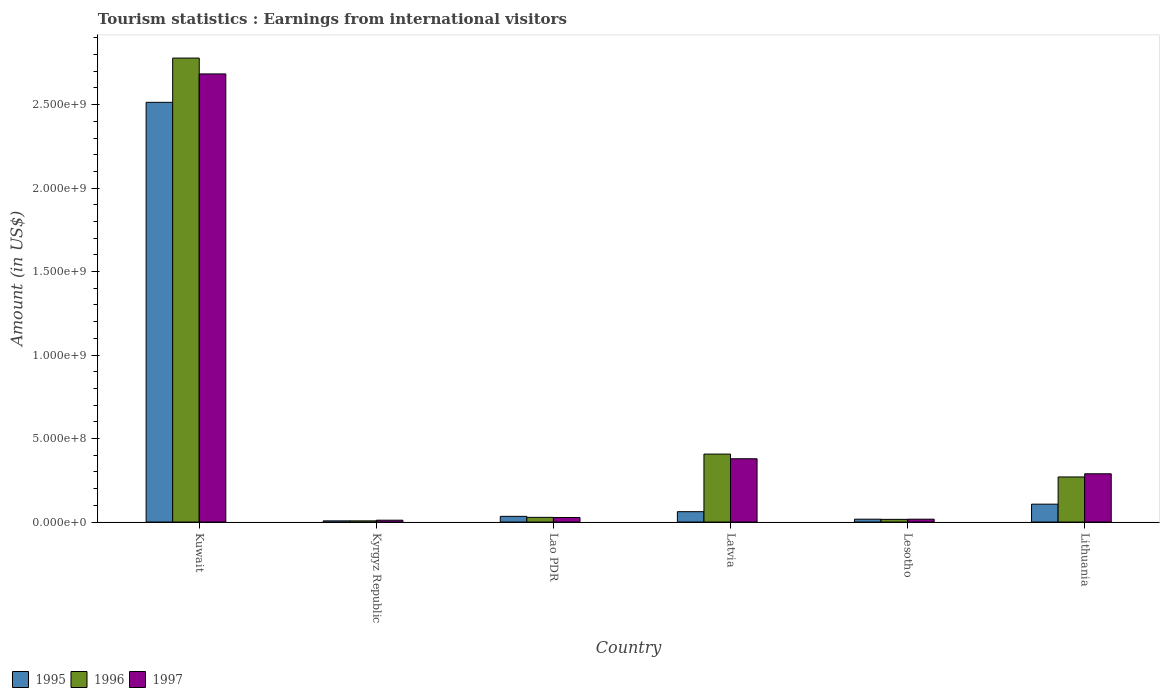What is the label of the 5th group of bars from the left?
Your answer should be compact. Lesotho. What is the earnings from international visitors in 1995 in Lao PDR?
Your response must be concise. 3.40e+07. Across all countries, what is the maximum earnings from international visitors in 1997?
Provide a short and direct response. 2.68e+09. Across all countries, what is the minimum earnings from international visitors in 1997?
Keep it short and to the point. 1.10e+07. In which country was the earnings from international visitors in 1997 maximum?
Make the answer very short. Kuwait. In which country was the earnings from international visitors in 1996 minimum?
Your answer should be compact. Kyrgyz Republic. What is the total earnings from international visitors in 1995 in the graph?
Keep it short and to the point. 2.74e+09. What is the difference between the earnings from international visitors in 1996 in Kuwait and that in Kyrgyz Republic?
Your response must be concise. 2.77e+09. What is the difference between the earnings from international visitors in 1996 in Kyrgyz Republic and the earnings from international visitors in 1997 in Lithuania?
Your answer should be compact. -2.82e+08. What is the average earnings from international visitors in 1996 per country?
Offer a terse response. 5.84e+08. What is the difference between the earnings from international visitors of/in 1997 and earnings from international visitors of/in 1995 in Lao PDR?
Make the answer very short. -7.00e+06. In how many countries, is the earnings from international visitors in 1995 greater than 1300000000 US$?
Keep it short and to the point. 1. What is the ratio of the earnings from international visitors in 1997 in Lao PDR to that in Latvia?
Provide a succinct answer. 0.07. Is the earnings from international visitors in 1996 in Lesotho less than that in Lithuania?
Ensure brevity in your answer.  Yes. What is the difference between the highest and the second highest earnings from international visitors in 1995?
Your answer should be very brief. 2.45e+09. What is the difference between the highest and the lowest earnings from international visitors in 1997?
Provide a succinct answer. 2.67e+09. What does the 1st bar from the right in Kyrgyz Republic represents?
Offer a terse response. 1997. How many bars are there?
Provide a succinct answer. 18. What is the difference between two consecutive major ticks on the Y-axis?
Provide a short and direct response. 5.00e+08. How many legend labels are there?
Your answer should be compact. 3. How are the legend labels stacked?
Offer a very short reply. Horizontal. What is the title of the graph?
Your answer should be very brief. Tourism statistics : Earnings from international visitors. Does "1982" appear as one of the legend labels in the graph?
Keep it short and to the point. No. What is the label or title of the X-axis?
Your response must be concise. Country. What is the label or title of the Y-axis?
Provide a succinct answer. Amount (in US$). What is the Amount (in US$) in 1995 in Kuwait?
Offer a very short reply. 2.51e+09. What is the Amount (in US$) in 1996 in Kuwait?
Keep it short and to the point. 2.78e+09. What is the Amount (in US$) of 1997 in Kuwait?
Ensure brevity in your answer.  2.68e+09. What is the Amount (in US$) of 1996 in Kyrgyz Republic?
Provide a succinct answer. 7.00e+06. What is the Amount (in US$) in 1997 in Kyrgyz Republic?
Your answer should be very brief. 1.10e+07. What is the Amount (in US$) of 1995 in Lao PDR?
Your answer should be very brief. 3.40e+07. What is the Amount (in US$) in 1996 in Lao PDR?
Offer a very short reply. 2.80e+07. What is the Amount (in US$) of 1997 in Lao PDR?
Offer a terse response. 2.70e+07. What is the Amount (in US$) in 1995 in Latvia?
Provide a short and direct response. 6.20e+07. What is the Amount (in US$) of 1996 in Latvia?
Your answer should be compact. 4.07e+08. What is the Amount (in US$) in 1997 in Latvia?
Offer a terse response. 3.79e+08. What is the Amount (in US$) of 1995 in Lesotho?
Provide a short and direct response. 1.70e+07. What is the Amount (in US$) of 1996 in Lesotho?
Provide a short and direct response. 1.60e+07. What is the Amount (in US$) of 1997 in Lesotho?
Your response must be concise. 1.70e+07. What is the Amount (in US$) of 1995 in Lithuania?
Your response must be concise. 1.07e+08. What is the Amount (in US$) in 1996 in Lithuania?
Ensure brevity in your answer.  2.70e+08. What is the Amount (in US$) in 1997 in Lithuania?
Provide a succinct answer. 2.89e+08. Across all countries, what is the maximum Amount (in US$) of 1995?
Make the answer very short. 2.51e+09. Across all countries, what is the maximum Amount (in US$) of 1996?
Keep it short and to the point. 2.78e+09. Across all countries, what is the maximum Amount (in US$) of 1997?
Offer a terse response. 2.68e+09. Across all countries, what is the minimum Amount (in US$) of 1995?
Your response must be concise. 7.00e+06. Across all countries, what is the minimum Amount (in US$) in 1997?
Offer a very short reply. 1.10e+07. What is the total Amount (in US$) of 1995 in the graph?
Offer a terse response. 2.74e+09. What is the total Amount (in US$) in 1996 in the graph?
Provide a succinct answer. 3.51e+09. What is the total Amount (in US$) in 1997 in the graph?
Provide a succinct answer. 3.41e+09. What is the difference between the Amount (in US$) in 1995 in Kuwait and that in Kyrgyz Republic?
Give a very brief answer. 2.51e+09. What is the difference between the Amount (in US$) of 1996 in Kuwait and that in Kyrgyz Republic?
Your response must be concise. 2.77e+09. What is the difference between the Amount (in US$) in 1997 in Kuwait and that in Kyrgyz Republic?
Offer a very short reply. 2.67e+09. What is the difference between the Amount (in US$) in 1995 in Kuwait and that in Lao PDR?
Ensure brevity in your answer.  2.48e+09. What is the difference between the Amount (in US$) of 1996 in Kuwait and that in Lao PDR?
Give a very brief answer. 2.75e+09. What is the difference between the Amount (in US$) of 1997 in Kuwait and that in Lao PDR?
Provide a succinct answer. 2.66e+09. What is the difference between the Amount (in US$) of 1995 in Kuwait and that in Latvia?
Your answer should be very brief. 2.45e+09. What is the difference between the Amount (in US$) of 1996 in Kuwait and that in Latvia?
Make the answer very short. 2.37e+09. What is the difference between the Amount (in US$) in 1997 in Kuwait and that in Latvia?
Your response must be concise. 2.30e+09. What is the difference between the Amount (in US$) in 1995 in Kuwait and that in Lesotho?
Offer a very short reply. 2.50e+09. What is the difference between the Amount (in US$) of 1996 in Kuwait and that in Lesotho?
Make the answer very short. 2.76e+09. What is the difference between the Amount (in US$) in 1997 in Kuwait and that in Lesotho?
Keep it short and to the point. 2.67e+09. What is the difference between the Amount (in US$) of 1995 in Kuwait and that in Lithuania?
Your response must be concise. 2.41e+09. What is the difference between the Amount (in US$) of 1996 in Kuwait and that in Lithuania?
Make the answer very short. 2.51e+09. What is the difference between the Amount (in US$) of 1997 in Kuwait and that in Lithuania?
Your answer should be compact. 2.40e+09. What is the difference between the Amount (in US$) of 1995 in Kyrgyz Republic and that in Lao PDR?
Your answer should be compact. -2.70e+07. What is the difference between the Amount (in US$) of 1996 in Kyrgyz Republic and that in Lao PDR?
Make the answer very short. -2.10e+07. What is the difference between the Amount (in US$) of 1997 in Kyrgyz Republic and that in Lao PDR?
Offer a terse response. -1.60e+07. What is the difference between the Amount (in US$) in 1995 in Kyrgyz Republic and that in Latvia?
Your answer should be very brief. -5.50e+07. What is the difference between the Amount (in US$) of 1996 in Kyrgyz Republic and that in Latvia?
Provide a short and direct response. -4.00e+08. What is the difference between the Amount (in US$) in 1997 in Kyrgyz Republic and that in Latvia?
Make the answer very short. -3.68e+08. What is the difference between the Amount (in US$) of 1995 in Kyrgyz Republic and that in Lesotho?
Your answer should be very brief. -1.00e+07. What is the difference between the Amount (in US$) of 1996 in Kyrgyz Republic and that in Lesotho?
Offer a very short reply. -9.00e+06. What is the difference between the Amount (in US$) in 1997 in Kyrgyz Republic and that in Lesotho?
Your answer should be very brief. -6.00e+06. What is the difference between the Amount (in US$) in 1995 in Kyrgyz Republic and that in Lithuania?
Provide a succinct answer. -1.00e+08. What is the difference between the Amount (in US$) in 1996 in Kyrgyz Republic and that in Lithuania?
Offer a very short reply. -2.63e+08. What is the difference between the Amount (in US$) of 1997 in Kyrgyz Republic and that in Lithuania?
Offer a very short reply. -2.78e+08. What is the difference between the Amount (in US$) in 1995 in Lao PDR and that in Latvia?
Keep it short and to the point. -2.80e+07. What is the difference between the Amount (in US$) in 1996 in Lao PDR and that in Latvia?
Ensure brevity in your answer.  -3.79e+08. What is the difference between the Amount (in US$) of 1997 in Lao PDR and that in Latvia?
Offer a very short reply. -3.52e+08. What is the difference between the Amount (in US$) in 1995 in Lao PDR and that in Lesotho?
Your answer should be compact. 1.70e+07. What is the difference between the Amount (in US$) of 1997 in Lao PDR and that in Lesotho?
Give a very brief answer. 1.00e+07. What is the difference between the Amount (in US$) of 1995 in Lao PDR and that in Lithuania?
Provide a succinct answer. -7.30e+07. What is the difference between the Amount (in US$) in 1996 in Lao PDR and that in Lithuania?
Offer a terse response. -2.42e+08. What is the difference between the Amount (in US$) in 1997 in Lao PDR and that in Lithuania?
Give a very brief answer. -2.62e+08. What is the difference between the Amount (in US$) in 1995 in Latvia and that in Lesotho?
Provide a short and direct response. 4.50e+07. What is the difference between the Amount (in US$) of 1996 in Latvia and that in Lesotho?
Offer a very short reply. 3.91e+08. What is the difference between the Amount (in US$) in 1997 in Latvia and that in Lesotho?
Keep it short and to the point. 3.62e+08. What is the difference between the Amount (in US$) of 1995 in Latvia and that in Lithuania?
Your answer should be compact. -4.50e+07. What is the difference between the Amount (in US$) in 1996 in Latvia and that in Lithuania?
Offer a very short reply. 1.37e+08. What is the difference between the Amount (in US$) of 1997 in Latvia and that in Lithuania?
Keep it short and to the point. 9.00e+07. What is the difference between the Amount (in US$) in 1995 in Lesotho and that in Lithuania?
Your answer should be very brief. -9.00e+07. What is the difference between the Amount (in US$) in 1996 in Lesotho and that in Lithuania?
Offer a very short reply. -2.54e+08. What is the difference between the Amount (in US$) of 1997 in Lesotho and that in Lithuania?
Keep it short and to the point. -2.72e+08. What is the difference between the Amount (in US$) of 1995 in Kuwait and the Amount (in US$) of 1996 in Kyrgyz Republic?
Provide a succinct answer. 2.51e+09. What is the difference between the Amount (in US$) of 1995 in Kuwait and the Amount (in US$) of 1997 in Kyrgyz Republic?
Keep it short and to the point. 2.50e+09. What is the difference between the Amount (in US$) in 1996 in Kuwait and the Amount (in US$) in 1997 in Kyrgyz Republic?
Your response must be concise. 2.77e+09. What is the difference between the Amount (in US$) in 1995 in Kuwait and the Amount (in US$) in 1996 in Lao PDR?
Your answer should be very brief. 2.49e+09. What is the difference between the Amount (in US$) of 1995 in Kuwait and the Amount (in US$) of 1997 in Lao PDR?
Make the answer very short. 2.49e+09. What is the difference between the Amount (in US$) of 1996 in Kuwait and the Amount (in US$) of 1997 in Lao PDR?
Provide a short and direct response. 2.75e+09. What is the difference between the Amount (in US$) of 1995 in Kuwait and the Amount (in US$) of 1996 in Latvia?
Give a very brief answer. 2.11e+09. What is the difference between the Amount (in US$) of 1995 in Kuwait and the Amount (in US$) of 1997 in Latvia?
Keep it short and to the point. 2.14e+09. What is the difference between the Amount (in US$) in 1996 in Kuwait and the Amount (in US$) in 1997 in Latvia?
Your answer should be very brief. 2.40e+09. What is the difference between the Amount (in US$) in 1995 in Kuwait and the Amount (in US$) in 1996 in Lesotho?
Offer a terse response. 2.50e+09. What is the difference between the Amount (in US$) in 1995 in Kuwait and the Amount (in US$) in 1997 in Lesotho?
Offer a very short reply. 2.50e+09. What is the difference between the Amount (in US$) of 1996 in Kuwait and the Amount (in US$) of 1997 in Lesotho?
Your response must be concise. 2.76e+09. What is the difference between the Amount (in US$) in 1995 in Kuwait and the Amount (in US$) in 1996 in Lithuania?
Make the answer very short. 2.24e+09. What is the difference between the Amount (in US$) of 1995 in Kuwait and the Amount (in US$) of 1997 in Lithuania?
Provide a short and direct response. 2.22e+09. What is the difference between the Amount (in US$) of 1996 in Kuwait and the Amount (in US$) of 1997 in Lithuania?
Give a very brief answer. 2.49e+09. What is the difference between the Amount (in US$) of 1995 in Kyrgyz Republic and the Amount (in US$) of 1996 in Lao PDR?
Provide a succinct answer. -2.10e+07. What is the difference between the Amount (in US$) in 1995 in Kyrgyz Republic and the Amount (in US$) in 1997 in Lao PDR?
Make the answer very short. -2.00e+07. What is the difference between the Amount (in US$) in 1996 in Kyrgyz Republic and the Amount (in US$) in 1997 in Lao PDR?
Provide a succinct answer. -2.00e+07. What is the difference between the Amount (in US$) in 1995 in Kyrgyz Republic and the Amount (in US$) in 1996 in Latvia?
Provide a succinct answer. -4.00e+08. What is the difference between the Amount (in US$) in 1995 in Kyrgyz Republic and the Amount (in US$) in 1997 in Latvia?
Provide a short and direct response. -3.72e+08. What is the difference between the Amount (in US$) in 1996 in Kyrgyz Republic and the Amount (in US$) in 1997 in Latvia?
Your answer should be compact. -3.72e+08. What is the difference between the Amount (in US$) in 1995 in Kyrgyz Republic and the Amount (in US$) in 1996 in Lesotho?
Keep it short and to the point. -9.00e+06. What is the difference between the Amount (in US$) of 1995 in Kyrgyz Republic and the Amount (in US$) of 1997 in Lesotho?
Your answer should be compact. -1.00e+07. What is the difference between the Amount (in US$) of 1996 in Kyrgyz Republic and the Amount (in US$) of 1997 in Lesotho?
Offer a very short reply. -1.00e+07. What is the difference between the Amount (in US$) of 1995 in Kyrgyz Republic and the Amount (in US$) of 1996 in Lithuania?
Your response must be concise. -2.63e+08. What is the difference between the Amount (in US$) of 1995 in Kyrgyz Republic and the Amount (in US$) of 1997 in Lithuania?
Provide a short and direct response. -2.82e+08. What is the difference between the Amount (in US$) in 1996 in Kyrgyz Republic and the Amount (in US$) in 1997 in Lithuania?
Offer a terse response. -2.82e+08. What is the difference between the Amount (in US$) of 1995 in Lao PDR and the Amount (in US$) of 1996 in Latvia?
Offer a terse response. -3.73e+08. What is the difference between the Amount (in US$) of 1995 in Lao PDR and the Amount (in US$) of 1997 in Latvia?
Offer a terse response. -3.45e+08. What is the difference between the Amount (in US$) of 1996 in Lao PDR and the Amount (in US$) of 1997 in Latvia?
Your answer should be very brief. -3.51e+08. What is the difference between the Amount (in US$) in 1995 in Lao PDR and the Amount (in US$) in 1996 in Lesotho?
Ensure brevity in your answer.  1.80e+07. What is the difference between the Amount (in US$) of 1995 in Lao PDR and the Amount (in US$) of 1997 in Lesotho?
Offer a very short reply. 1.70e+07. What is the difference between the Amount (in US$) of 1996 in Lao PDR and the Amount (in US$) of 1997 in Lesotho?
Provide a succinct answer. 1.10e+07. What is the difference between the Amount (in US$) of 1995 in Lao PDR and the Amount (in US$) of 1996 in Lithuania?
Offer a very short reply. -2.36e+08. What is the difference between the Amount (in US$) in 1995 in Lao PDR and the Amount (in US$) in 1997 in Lithuania?
Keep it short and to the point. -2.55e+08. What is the difference between the Amount (in US$) in 1996 in Lao PDR and the Amount (in US$) in 1997 in Lithuania?
Your answer should be very brief. -2.61e+08. What is the difference between the Amount (in US$) of 1995 in Latvia and the Amount (in US$) of 1996 in Lesotho?
Offer a very short reply. 4.60e+07. What is the difference between the Amount (in US$) of 1995 in Latvia and the Amount (in US$) of 1997 in Lesotho?
Ensure brevity in your answer.  4.50e+07. What is the difference between the Amount (in US$) of 1996 in Latvia and the Amount (in US$) of 1997 in Lesotho?
Your response must be concise. 3.90e+08. What is the difference between the Amount (in US$) in 1995 in Latvia and the Amount (in US$) in 1996 in Lithuania?
Give a very brief answer. -2.08e+08. What is the difference between the Amount (in US$) of 1995 in Latvia and the Amount (in US$) of 1997 in Lithuania?
Ensure brevity in your answer.  -2.27e+08. What is the difference between the Amount (in US$) in 1996 in Latvia and the Amount (in US$) in 1997 in Lithuania?
Your response must be concise. 1.18e+08. What is the difference between the Amount (in US$) in 1995 in Lesotho and the Amount (in US$) in 1996 in Lithuania?
Offer a very short reply. -2.53e+08. What is the difference between the Amount (in US$) of 1995 in Lesotho and the Amount (in US$) of 1997 in Lithuania?
Your answer should be compact. -2.72e+08. What is the difference between the Amount (in US$) in 1996 in Lesotho and the Amount (in US$) in 1997 in Lithuania?
Ensure brevity in your answer.  -2.73e+08. What is the average Amount (in US$) of 1995 per country?
Offer a very short reply. 4.57e+08. What is the average Amount (in US$) of 1996 per country?
Your answer should be compact. 5.84e+08. What is the average Amount (in US$) in 1997 per country?
Provide a succinct answer. 5.68e+08. What is the difference between the Amount (in US$) in 1995 and Amount (in US$) in 1996 in Kuwait?
Keep it short and to the point. -2.65e+08. What is the difference between the Amount (in US$) of 1995 and Amount (in US$) of 1997 in Kuwait?
Provide a short and direct response. -1.70e+08. What is the difference between the Amount (in US$) in 1996 and Amount (in US$) in 1997 in Kuwait?
Make the answer very short. 9.50e+07. What is the difference between the Amount (in US$) of 1995 and Amount (in US$) of 1997 in Kyrgyz Republic?
Offer a very short reply. -4.00e+06. What is the difference between the Amount (in US$) in 1996 and Amount (in US$) in 1997 in Kyrgyz Republic?
Provide a succinct answer. -4.00e+06. What is the difference between the Amount (in US$) in 1995 and Amount (in US$) in 1996 in Lao PDR?
Give a very brief answer. 6.00e+06. What is the difference between the Amount (in US$) of 1995 and Amount (in US$) of 1997 in Lao PDR?
Keep it short and to the point. 7.00e+06. What is the difference between the Amount (in US$) in 1996 and Amount (in US$) in 1997 in Lao PDR?
Your response must be concise. 1.00e+06. What is the difference between the Amount (in US$) of 1995 and Amount (in US$) of 1996 in Latvia?
Your answer should be very brief. -3.45e+08. What is the difference between the Amount (in US$) of 1995 and Amount (in US$) of 1997 in Latvia?
Your answer should be compact. -3.17e+08. What is the difference between the Amount (in US$) in 1996 and Amount (in US$) in 1997 in Latvia?
Your answer should be compact. 2.80e+07. What is the difference between the Amount (in US$) in 1995 and Amount (in US$) in 1996 in Lesotho?
Keep it short and to the point. 1.00e+06. What is the difference between the Amount (in US$) in 1995 and Amount (in US$) in 1997 in Lesotho?
Ensure brevity in your answer.  0. What is the difference between the Amount (in US$) of 1995 and Amount (in US$) of 1996 in Lithuania?
Ensure brevity in your answer.  -1.63e+08. What is the difference between the Amount (in US$) in 1995 and Amount (in US$) in 1997 in Lithuania?
Provide a short and direct response. -1.82e+08. What is the difference between the Amount (in US$) of 1996 and Amount (in US$) of 1997 in Lithuania?
Offer a terse response. -1.90e+07. What is the ratio of the Amount (in US$) of 1995 in Kuwait to that in Kyrgyz Republic?
Keep it short and to the point. 359.14. What is the ratio of the Amount (in US$) of 1996 in Kuwait to that in Kyrgyz Republic?
Give a very brief answer. 397. What is the ratio of the Amount (in US$) of 1997 in Kuwait to that in Kyrgyz Republic?
Provide a succinct answer. 244. What is the ratio of the Amount (in US$) in 1995 in Kuwait to that in Lao PDR?
Offer a terse response. 73.94. What is the ratio of the Amount (in US$) in 1996 in Kuwait to that in Lao PDR?
Your response must be concise. 99.25. What is the ratio of the Amount (in US$) of 1997 in Kuwait to that in Lao PDR?
Ensure brevity in your answer.  99.41. What is the ratio of the Amount (in US$) in 1995 in Kuwait to that in Latvia?
Give a very brief answer. 40.55. What is the ratio of the Amount (in US$) of 1996 in Kuwait to that in Latvia?
Give a very brief answer. 6.83. What is the ratio of the Amount (in US$) of 1997 in Kuwait to that in Latvia?
Provide a short and direct response. 7.08. What is the ratio of the Amount (in US$) of 1995 in Kuwait to that in Lesotho?
Provide a succinct answer. 147.88. What is the ratio of the Amount (in US$) of 1996 in Kuwait to that in Lesotho?
Offer a very short reply. 173.69. What is the ratio of the Amount (in US$) of 1997 in Kuwait to that in Lesotho?
Your answer should be very brief. 157.88. What is the ratio of the Amount (in US$) in 1995 in Kuwait to that in Lithuania?
Keep it short and to the point. 23.5. What is the ratio of the Amount (in US$) in 1996 in Kuwait to that in Lithuania?
Your answer should be very brief. 10.29. What is the ratio of the Amount (in US$) of 1997 in Kuwait to that in Lithuania?
Your response must be concise. 9.29. What is the ratio of the Amount (in US$) of 1995 in Kyrgyz Republic to that in Lao PDR?
Ensure brevity in your answer.  0.21. What is the ratio of the Amount (in US$) in 1996 in Kyrgyz Republic to that in Lao PDR?
Make the answer very short. 0.25. What is the ratio of the Amount (in US$) in 1997 in Kyrgyz Republic to that in Lao PDR?
Keep it short and to the point. 0.41. What is the ratio of the Amount (in US$) in 1995 in Kyrgyz Republic to that in Latvia?
Provide a succinct answer. 0.11. What is the ratio of the Amount (in US$) of 1996 in Kyrgyz Republic to that in Latvia?
Your answer should be very brief. 0.02. What is the ratio of the Amount (in US$) of 1997 in Kyrgyz Republic to that in Latvia?
Make the answer very short. 0.03. What is the ratio of the Amount (in US$) in 1995 in Kyrgyz Republic to that in Lesotho?
Offer a terse response. 0.41. What is the ratio of the Amount (in US$) in 1996 in Kyrgyz Republic to that in Lesotho?
Your response must be concise. 0.44. What is the ratio of the Amount (in US$) of 1997 in Kyrgyz Republic to that in Lesotho?
Your answer should be compact. 0.65. What is the ratio of the Amount (in US$) of 1995 in Kyrgyz Republic to that in Lithuania?
Your answer should be compact. 0.07. What is the ratio of the Amount (in US$) in 1996 in Kyrgyz Republic to that in Lithuania?
Make the answer very short. 0.03. What is the ratio of the Amount (in US$) of 1997 in Kyrgyz Republic to that in Lithuania?
Give a very brief answer. 0.04. What is the ratio of the Amount (in US$) in 1995 in Lao PDR to that in Latvia?
Keep it short and to the point. 0.55. What is the ratio of the Amount (in US$) of 1996 in Lao PDR to that in Latvia?
Your answer should be compact. 0.07. What is the ratio of the Amount (in US$) in 1997 in Lao PDR to that in Latvia?
Provide a succinct answer. 0.07. What is the ratio of the Amount (in US$) of 1995 in Lao PDR to that in Lesotho?
Your answer should be very brief. 2. What is the ratio of the Amount (in US$) in 1996 in Lao PDR to that in Lesotho?
Your response must be concise. 1.75. What is the ratio of the Amount (in US$) of 1997 in Lao PDR to that in Lesotho?
Give a very brief answer. 1.59. What is the ratio of the Amount (in US$) in 1995 in Lao PDR to that in Lithuania?
Provide a succinct answer. 0.32. What is the ratio of the Amount (in US$) of 1996 in Lao PDR to that in Lithuania?
Provide a succinct answer. 0.1. What is the ratio of the Amount (in US$) in 1997 in Lao PDR to that in Lithuania?
Provide a succinct answer. 0.09. What is the ratio of the Amount (in US$) of 1995 in Latvia to that in Lesotho?
Your response must be concise. 3.65. What is the ratio of the Amount (in US$) in 1996 in Latvia to that in Lesotho?
Keep it short and to the point. 25.44. What is the ratio of the Amount (in US$) in 1997 in Latvia to that in Lesotho?
Provide a short and direct response. 22.29. What is the ratio of the Amount (in US$) in 1995 in Latvia to that in Lithuania?
Your answer should be compact. 0.58. What is the ratio of the Amount (in US$) in 1996 in Latvia to that in Lithuania?
Ensure brevity in your answer.  1.51. What is the ratio of the Amount (in US$) in 1997 in Latvia to that in Lithuania?
Your response must be concise. 1.31. What is the ratio of the Amount (in US$) in 1995 in Lesotho to that in Lithuania?
Keep it short and to the point. 0.16. What is the ratio of the Amount (in US$) of 1996 in Lesotho to that in Lithuania?
Your answer should be compact. 0.06. What is the ratio of the Amount (in US$) of 1997 in Lesotho to that in Lithuania?
Give a very brief answer. 0.06. What is the difference between the highest and the second highest Amount (in US$) of 1995?
Ensure brevity in your answer.  2.41e+09. What is the difference between the highest and the second highest Amount (in US$) in 1996?
Provide a succinct answer. 2.37e+09. What is the difference between the highest and the second highest Amount (in US$) of 1997?
Provide a short and direct response. 2.30e+09. What is the difference between the highest and the lowest Amount (in US$) of 1995?
Provide a succinct answer. 2.51e+09. What is the difference between the highest and the lowest Amount (in US$) of 1996?
Ensure brevity in your answer.  2.77e+09. What is the difference between the highest and the lowest Amount (in US$) in 1997?
Offer a very short reply. 2.67e+09. 